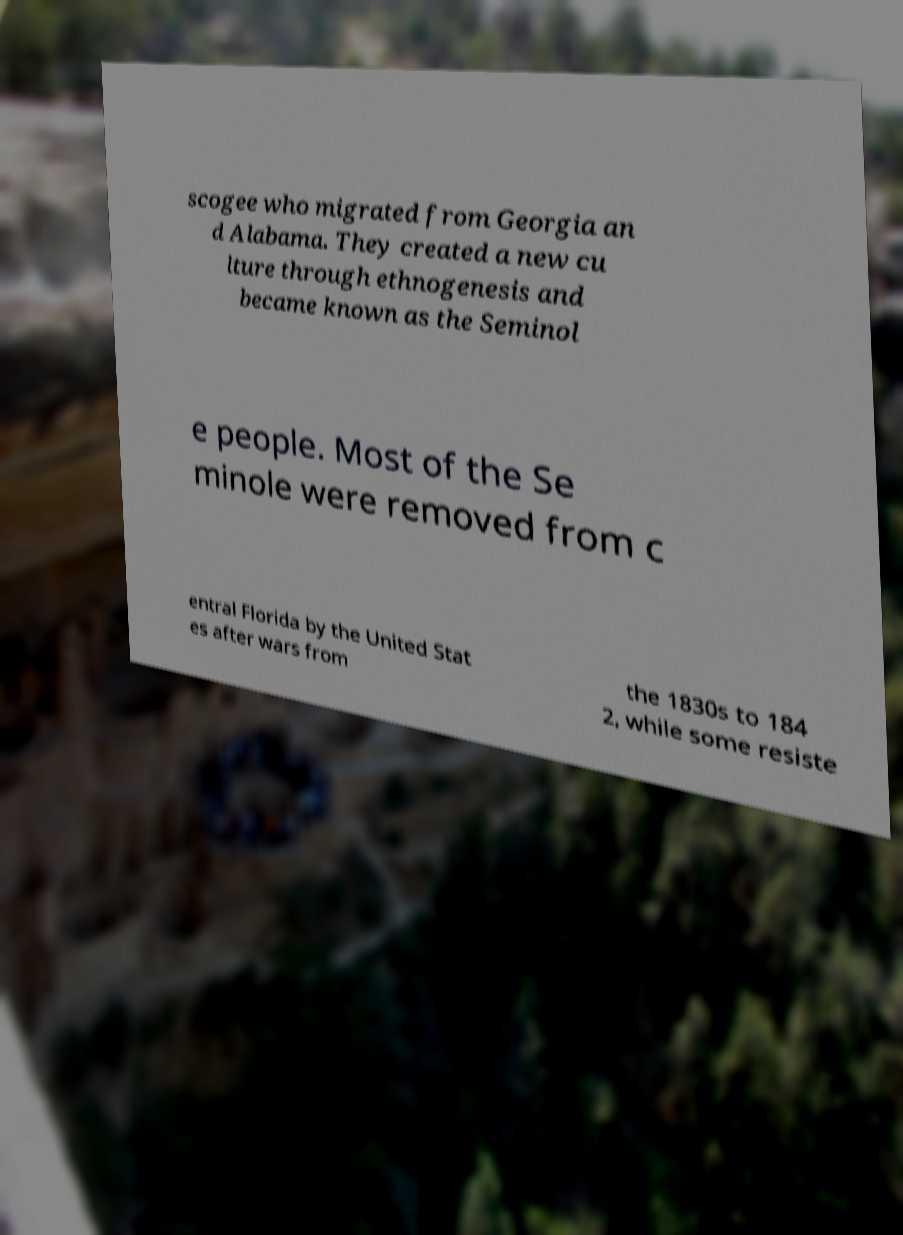What messages or text are displayed in this image? I need them in a readable, typed format. scogee who migrated from Georgia an d Alabama. They created a new cu lture through ethnogenesis and became known as the Seminol e people. Most of the Se minole were removed from c entral Florida by the United Stat es after wars from the 1830s to 184 2, while some resiste 